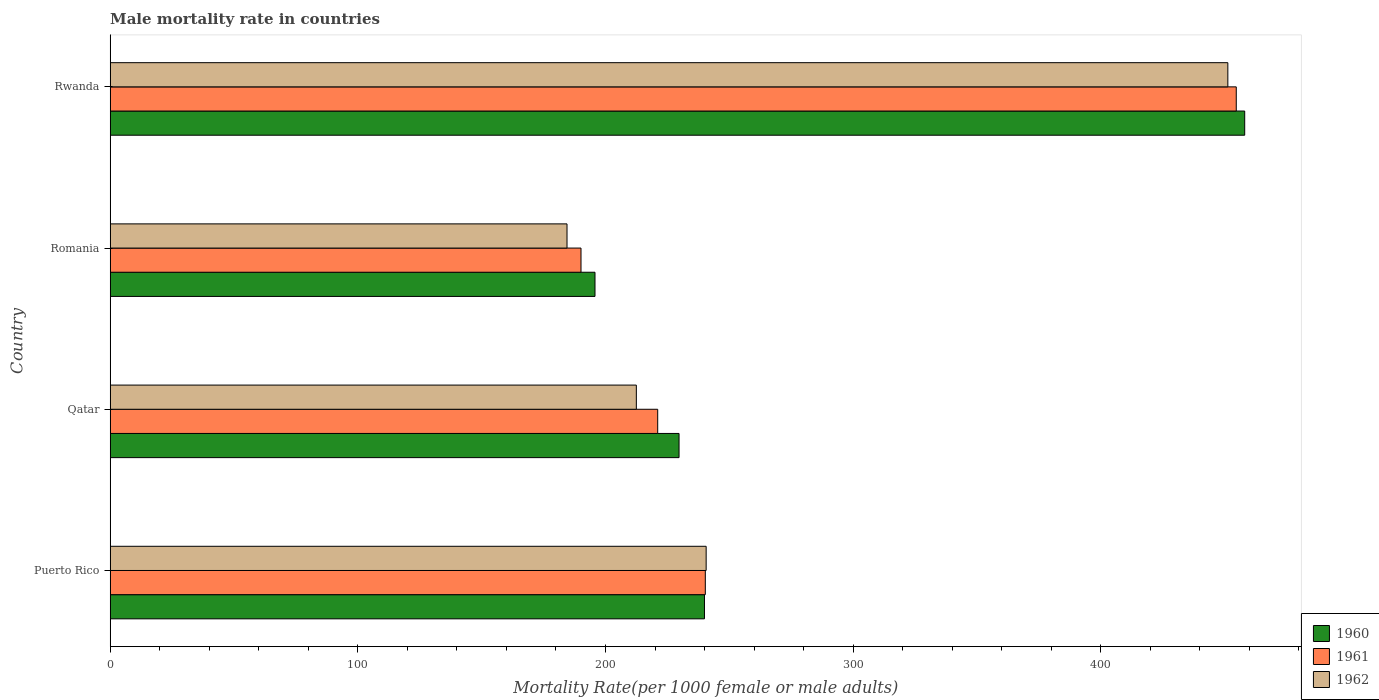How many different coloured bars are there?
Your answer should be compact. 3. How many groups of bars are there?
Make the answer very short. 4. Are the number of bars on each tick of the Y-axis equal?
Offer a very short reply. Yes. How many bars are there on the 2nd tick from the bottom?
Your response must be concise. 3. What is the label of the 1st group of bars from the top?
Offer a very short reply. Rwanda. What is the male mortality rate in 1962 in Romania?
Offer a very short reply. 184.47. Across all countries, what is the maximum male mortality rate in 1960?
Give a very brief answer. 458.1. Across all countries, what is the minimum male mortality rate in 1960?
Make the answer very short. 195.77. In which country was the male mortality rate in 1960 maximum?
Your response must be concise. Rwanda. In which country was the male mortality rate in 1962 minimum?
Make the answer very short. Romania. What is the total male mortality rate in 1960 in the graph?
Provide a succinct answer. 1123.53. What is the difference between the male mortality rate in 1962 in Puerto Rico and that in Romania?
Keep it short and to the point. 56.18. What is the difference between the male mortality rate in 1962 in Qatar and the male mortality rate in 1960 in Puerto Rico?
Your answer should be very brief. -27.51. What is the average male mortality rate in 1962 per country?
Offer a terse response. 272.22. What is the difference between the male mortality rate in 1962 and male mortality rate in 1960 in Qatar?
Ensure brevity in your answer.  -17.25. In how many countries, is the male mortality rate in 1962 greater than 400 ?
Ensure brevity in your answer.  1. What is the ratio of the male mortality rate in 1962 in Puerto Rico to that in Rwanda?
Your response must be concise. 0.53. Is the male mortality rate in 1960 in Qatar less than that in Rwanda?
Offer a terse response. Yes. Is the difference between the male mortality rate in 1962 in Puerto Rico and Qatar greater than the difference between the male mortality rate in 1960 in Puerto Rico and Qatar?
Offer a very short reply. Yes. What is the difference between the highest and the second highest male mortality rate in 1960?
Your answer should be very brief. 218.13. What is the difference between the highest and the lowest male mortality rate in 1960?
Give a very brief answer. 262.33. In how many countries, is the male mortality rate in 1961 greater than the average male mortality rate in 1961 taken over all countries?
Your answer should be compact. 1. What does the 2nd bar from the bottom in Puerto Rico represents?
Give a very brief answer. 1961. Is it the case that in every country, the sum of the male mortality rate in 1961 and male mortality rate in 1960 is greater than the male mortality rate in 1962?
Your answer should be compact. Yes. Are all the bars in the graph horizontal?
Your answer should be compact. Yes. How many countries are there in the graph?
Provide a short and direct response. 4. Where does the legend appear in the graph?
Ensure brevity in your answer.  Bottom right. How are the legend labels stacked?
Ensure brevity in your answer.  Vertical. What is the title of the graph?
Your answer should be compact. Male mortality rate in countries. What is the label or title of the X-axis?
Make the answer very short. Mortality Rate(per 1000 female or male adults). What is the label or title of the Y-axis?
Offer a terse response. Country. What is the Mortality Rate(per 1000 female or male adults) of 1960 in Puerto Rico?
Offer a terse response. 239.97. What is the Mortality Rate(per 1000 female or male adults) of 1961 in Puerto Rico?
Offer a terse response. 240.31. What is the Mortality Rate(per 1000 female or male adults) of 1962 in Puerto Rico?
Offer a very short reply. 240.65. What is the Mortality Rate(per 1000 female or male adults) in 1960 in Qatar?
Your answer should be very brief. 229.71. What is the Mortality Rate(per 1000 female or male adults) of 1961 in Qatar?
Your answer should be very brief. 221.08. What is the Mortality Rate(per 1000 female or male adults) in 1962 in Qatar?
Provide a short and direct response. 212.46. What is the Mortality Rate(per 1000 female or male adults) of 1960 in Romania?
Provide a short and direct response. 195.77. What is the Mortality Rate(per 1000 female or male adults) of 1961 in Romania?
Offer a terse response. 190.12. What is the Mortality Rate(per 1000 female or male adults) in 1962 in Romania?
Keep it short and to the point. 184.47. What is the Mortality Rate(per 1000 female or male adults) in 1960 in Rwanda?
Make the answer very short. 458.1. What is the Mortality Rate(per 1000 female or male adults) in 1961 in Rwanda?
Your answer should be compact. 454.69. What is the Mortality Rate(per 1000 female or male adults) in 1962 in Rwanda?
Offer a very short reply. 451.29. Across all countries, what is the maximum Mortality Rate(per 1000 female or male adults) of 1960?
Offer a very short reply. 458.1. Across all countries, what is the maximum Mortality Rate(per 1000 female or male adults) in 1961?
Ensure brevity in your answer.  454.69. Across all countries, what is the maximum Mortality Rate(per 1000 female or male adults) in 1962?
Your answer should be very brief. 451.29. Across all countries, what is the minimum Mortality Rate(per 1000 female or male adults) of 1960?
Offer a very short reply. 195.77. Across all countries, what is the minimum Mortality Rate(per 1000 female or male adults) of 1961?
Give a very brief answer. 190.12. Across all countries, what is the minimum Mortality Rate(per 1000 female or male adults) of 1962?
Ensure brevity in your answer.  184.47. What is the total Mortality Rate(per 1000 female or male adults) in 1960 in the graph?
Offer a very short reply. 1123.54. What is the total Mortality Rate(per 1000 female or male adults) of 1961 in the graph?
Offer a terse response. 1106.2. What is the total Mortality Rate(per 1000 female or male adults) in 1962 in the graph?
Your answer should be compact. 1088.87. What is the difference between the Mortality Rate(per 1000 female or male adults) in 1960 in Puerto Rico and that in Qatar?
Your answer should be compact. 10.26. What is the difference between the Mortality Rate(per 1000 female or male adults) in 1961 in Puerto Rico and that in Qatar?
Ensure brevity in your answer.  19.23. What is the difference between the Mortality Rate(per 1000 female or male adults) of 1962 in Puerto Rico and that in Qatar?
Give a very brief answer. 28.19. What is the difference between the Mortality Rate(per 1000 female or male adults) in 1960 in Puerto Rico and that in Romania?
Your answer should be compact. 44.2. What is the difference between the Mortality Rate(per 1000 female or male adults) of 1961 in Puerto Rico and that in Romania?
Your answer should be compact. 50.19. What is the difference between the Mortality Rate(per 1000 female or male adults) in 1962 in Puerto Rico and that in Romania?
Keep it short and to the point. 56.18. What is the difference between the Mortality Rate(per 1000 female or male adults) of 1960 in Puerto Rico and that in Rwanda?
Offer a terse response. -218.13. What is the difference between the Mortality Rate(per 1000 female or male adults) in 1961 in Puerto Rico and that in Rwanda?
Give a very brief answer. -214.38. What is the difference between the Mortality Rate(per 1000 female or male adults) in 1962 in Puerto Rico and that in Rwanda?
Ensure brevity in your answer.  -210.64. What is the difference between the Mortality Rate(per 1000 female or male adults) in 1960 in Qatar and that in Romania?
Keep it short and to the point. 33.94. What is the difference between the Mortality Rate(per 1000 female or male adults) in 1961 in Qatar and that in Romania?
Keep it short and to the point. 30.97. What is the difference between the Mortality Rate(per 1000 female or male adults) in 1962 in Qatar and that in Romania?
Make the answer very short. 27.99. What is the difference between the Mortality Rate(per 1000 female or male adults) in 1960 in Qatar and that in Rwanda?
Provide a succinct answer. -228.39. What is the difference between the Mortality Rate(per 1000 female or male adults) in 1961 in Qatar and that in Rwanda?
Your answer should be very brief. -233.61. What is the difference between the Mortality Rate(per 1000 female or male adults) of 1962 in Qatar and that in Rwanda?
Provide a short and direct response. -238.83. What is the difference between the Mortality Rate(per 1000 female or male adults) of 1960 in Romania and that in Rwanda?
Keep it short and to the point. -262.33. What is the difference between the Mortality Rate(per 1000 female or male adults) of 1961 in Romania and that in Rwanda?
Ensure brevity in your answer.  -264.57. What is the difference between the Mortality Rate(per 1000 female or male adults) in 1962 in Romania and that in Rwanda?
Your answer should be compact. -266.82. What is the difference between the Mortality Rate(per 1000 female or male adults) in 1960 in Puerto Rico and the Mortality Rate(per 1000 female or male adults) in 1961 in Qatar?
Your response must be concise. 18.88. What is the difference between the Mortality Rate(per 1000 female or male adults) of 1960 in Puerto Rico and the Mortality Rate(per 1000 female or male adults) of 1962 in Qatar?
Make the answer very short. 27.51. What is the difference between the Mortality Rate(per 1000 female or male adults) in 1961 in Puerto Rico and the Mortality Rate(per 1000 female or male adults) in 1962 in Qatar?
Keep it short and to the point. 27.85. What is the difference between the Mortality Rate(per 1000 female or male adults) of 1960 in Puerto Rico and the Mortality Rate(per 1000 female or male adults) of 1961 in Romania?
Give a very brief answer. 49.85. What is the difference between the Mortality Rate(per 1000 female or male adults) of 1960 in Puerto Rico and the Mortality Rate(per 1000 female or male adults) of 1962 in Romania?
Offer a terse response. 55.5. What is the difference between the Mortality Rate(per 1000 female or male adults) in 1961 in Puerto Rico and the Mortality Rate(per 1000 female or male adults) in 1962 in Romania?
Offer a very short reply. 55.84. What is the difference between the Mortality Rate(per 1000 female or male adults) of 1960 in Puerto Rico and the Mortality Rate(per 1000 female or male adults) of 1961 in Rwanda?
Offer a terse response. -214.73. What is the difference between the Mortality Rate(per 1000 female or male adults) in 1960 in Puerto Rico and the Mortality Rate(per 1000 female or male adults) in 1962 in Rwanda?
Your answer should be very brief. -211.32. What is the difference between the Mortality Rate(per 1000 female or male adults) in 1961 in Puerto Rico and the Mortality Rate(per 1000 female or male adults) in 1962 in Rwanda?
Your response must be concise. -210.98. What is the difference between the Mortality Rate(per 1000 female or male adults) in 1960 in Qatar and the Mortality Rate(per 1000 female or male adults) in 1961 in Romania?
Provide a succinct answer. 39.59. What is the difference between the Mortality Rate(per 1000 female or male adults) in 1960 in Qatar and the Mortality Rate(per 1000 female or male adults) in 1962 in Romania?
Give a very brief answer. 45.24. What is the difference between the Mortality Rate(per 1000 female or male adults) of 1961 in Qatar and the Mortality Rate(per 1000 female or male adults) of 1962 in Romania?
Provide a succinct answer. 36.61. What is the difference between the Mortality Rate(per 1000 female or male adults) of 1960 in Qatar and the Mortality Rate(per 1000 female or male adults) of 1961 in Rwanda?
Provide a succinct answer. -224.99. What is the difference between the Mortality Rate(per 1000 female or male adults) of 1960 in Qatar and the Mortality Rate(per 1000 female or male adults) of 1962 in Rwanda?
Your answer should be compact. -221.58. What is the difference between the Mortality Rate(per 1000 female or male adults) of 1961 in Qatar and the Mortality Rate(per 1000 female or male adults) of 1962 in Rwanda?
Your answer should be compact. -230.21. What is the difference between the Mortality Rate(per 1000 female or male adults) in 1960 in Romania and the Mortality Rate(per 1000 female or male adults) in 1961 in Rwanda?
Give a very brief answer. -258.93. What is the difference between the Mortality Rate(per 1000 female or male adults) in 1960 in Romania and the Mortality Rate(per 1000 female or male adults) in 1962 in Rwanda?
Make the answer very short. -255.52. What is the difference between the Mortality Rate(per 1000 female or male adults) of 1961 in Romania and the Mortality Rate(per 1000 female or male adults) of 1962 in Rwanda?
Offer a very short reply. -261.17. What is the average Mortality Rate(per 1000 female or male adults) of 1960 per country?
Provide a short and direct response. 280.88. What is the average Mortality Rate(per 1000 female or male adults) of 1961 per country?
Offer a very short reply. 276.55. What is the average Mortality Rate(per 1000 female or male adults) of 1962 per country?
Provide a short and direct response. 272.22. What is the difference between the Mortality Rate(per 1000 female or male adults) of 1960 and Mortality Rate(per 1000 female or male adults) of 1961 in Puerto Rico?
Provide a short and direct response. -0.34. What is the difference between the Mortality Rate(per 1000 female or male adults) in 1960 and Mortality Rate(per 1000 female or male adults) in 1962 in Puerto Rico?
Provide a succinct answer. -0.68. What is the difference between the Mortality Rate(per 1000 female or male adults) of 1961 and Mortality Rate(per 1000 female or male adults) of 1962 in Puerto Rico?
Offer a very short reply. -0.34. What is the difference between the Mortality Rate(per 1000 female or male adults) of 1960 and Mortality Rate(per 1000 female or male adults) of 1961 in Qatar?
Provide a short and direct response. 8.62. What is the difference between the Mortality Rate(per 1000 female or male adults) in 1960 and Mortality Rate(per 1000 female or male adults) in 1962 in Qatar?
Provide a succinct answer. 17.25. What is the difference between the Mortality Rate(per 1000 female or male adults) in 1961 and Mortality Rate(per 1000 female or male adults) in 1962 in Qatar?
Your answer should be very brief. 8.62. What is the difference between the Mortality Rate(per 1000 female or male adults) of 1960 and Mortality Rate(per 1000 female or male adults) of 1961 in Romania?
Make the answer very short. 5.65. What is the difference between the Mortality Rate(per 1000 female or male adults) of 1960 and Mortality Rate(per 1000 female or male adults) of 1962 in Romania?
Your response must be concise. 11.3. What is the difference between the Mortality Rate(per 1000 female or male adults) in 1961 and Mortality Rate(per 1000 female or male adults) in 1962 in Romania?
Your answer should be very brief. 5.65. What is the difference between the Mortality Rate(per 1000 female or male adults) in 1960 and Mortality Rate(per 1000 female or male adults) in 1961 in Rwanda?
Offer a terse response. 3.4. What is the difference between the Mortality Rate(per 1000 female or male adults) in 1960 and Mortality Rate(per 1000 female or male adults) in 1962 in Rwanda?
Provide a succinct answer. 6.81. What is the difference between the Mortality Rate(per 1000 female or male adults) in 1961 and Mortality Rate(per 1000 female or male adults) in 1962 in Rwanda?
Offer a terse response. 3.4. What is the ratio of the Mortality Rate(per 1000 female or male adults) in 1960 in Puerto Rico to that in Qatar?
Offer a very short reply. 1.04. What is the ratio of the Mortality Rate(per 1000 female or male adults) of 1961 in Puerto Rico to that in Qatar?
Offer a terse response. 1.09. What is the ratio of the Mortality Rate(per 1000 female or male adults) of 1962 in Puerto Rico to that in Qatar?
Offer a terse response. 1.13. What is the ratio of the Mortality Rate(per 1000 female or male adults) in 1960 in Puerto Rico to that in Romania?
Offer a terse response. 1.23. What is the ratio of the Mortality Rate(per 1000 female or male adults) in 1961 in Puerto Rico to that in Romania?
Give a very brief answer. 1.26. What is the ratio of the Mortality Rate(per 1000 female or male adults) in 1962 in Puerto Rico to that in Romania?
Keep it short and to the point. 1.3. What is the ratio of the Mortality Rate(per 1000 female or male adults) in 1960 in Puerto Rico to that in Rwanda?
Your response must be concise. 0.52. What is the ratio of the Mortality Rate(per 1000 female or male adults) in 1961 in Puerto Rico to that in Rwanda?
Your answer should be compact. 0.53. What is the ratio of the Mortality Rate(per 1000 female or male adults) of 1962 in Puerto Rico to that in Rwanda?
Make the answer very short. 0.53. What is the ratio of the Mortality Rate(per 1000 female or male adults) in 1960 in Qatar to that in Romania?
Offer a very short reply. 1.17. What is the ratio of the Mortality Rate(per 1000 female or male adults) of 1961 in Qatar to that in Romania?
Offer a terse response. 1.16. What is the ratio of the Mortality Rate(per 1000 female or male adults) of 1962 in Qatar to that in Romania?
Ensure brevity in your answer.  1.15. What is the ratio of the Mortality Rate(per 1000 female or male adults) in 1960 in Qatar to that in Rwanda?
Offer a terse response. 0.5. What is the ratio of the Mortality Rate(per 1000 female or male adults) in 1961 in Qatar to that in Rwanda?
Offer a terse response. 0.49. What is the ratio of the Mortality Rate(per 1000 female or male adults) of 1962 in Qatar to that in Rwanda?
Keep it short and to the point. 0.47. What is the ratio of the Mortality Rate(per 1000 female or male adults) in 1960 in Romania to that in Rwanda?
Make the answer very short. 0.43. What is the ratio of the Mortality Rate(per 1000 female or male adults) of 1961 in Romania to that in Rwanda?
Ensure brevity in your answer.  0.42. What is the ratio of the Mortality Rate(per 1000 female or male adults) in 1962 in Romania to that in Rwanda?
Make the answer very short. 0.41. What is the difference between the highest and the second highest Mortality Rate(per 1000 female or male adults) in 1960?
Ensure brevity in your answer.  218.13. What is the difference between the highest and the second highest Mortality Rate(per 1000 female or male adults) of 1961?
Keep it short and to the point. 214.38. What is the difference between the highest and the second highest Mortality Rate(per 1000 female or male adults) of 1962?
Provide a short and direct response. 210.64. What is the difference between the highest and the lowest Mortality Rate(per 1000 female or male adults) in 1960?
Give a very brief answer. 262.33. What is the difference between the highest and the lowest Mortality Rate(per 1000 female or male adults) of 1961?
Keep it short and to the point. 264.57. What is the difference between the highest and the lowest Mortality Rate(per 1000 female or male adults) of 1962?
Offer a terse response. 266.82. 